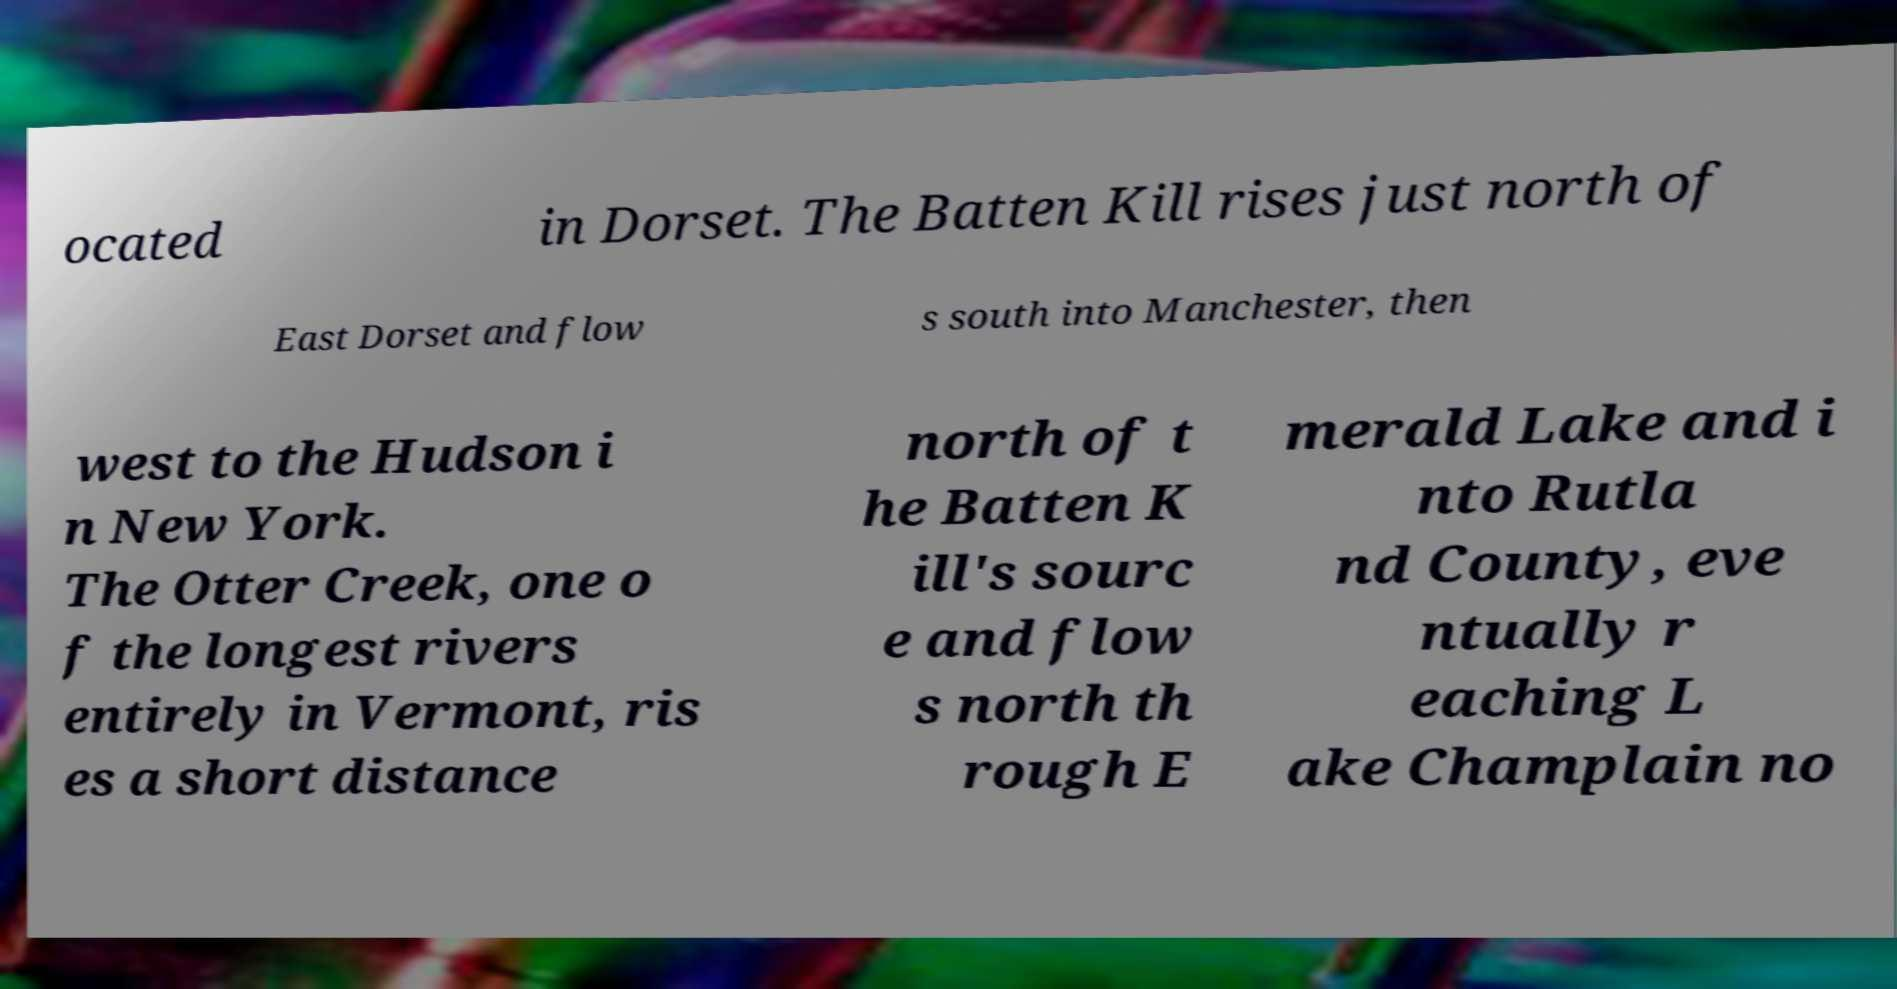There's text embedded in this image that I need extracted. Can you transcribe it verbatim? ocated in Dorset. The Batten Kill rises just north of East Dorset and flow s south into Manchester, then west to the Hudson i n New York. The Otter Creek, one o f the longest rivers entirely in Vermont, ris es a short distance north of t he Batten K ill's sourc e and flow s north th rough E merald Lake and i nto Rutla nd County, eve ntually r eaching L ake Champlain no 